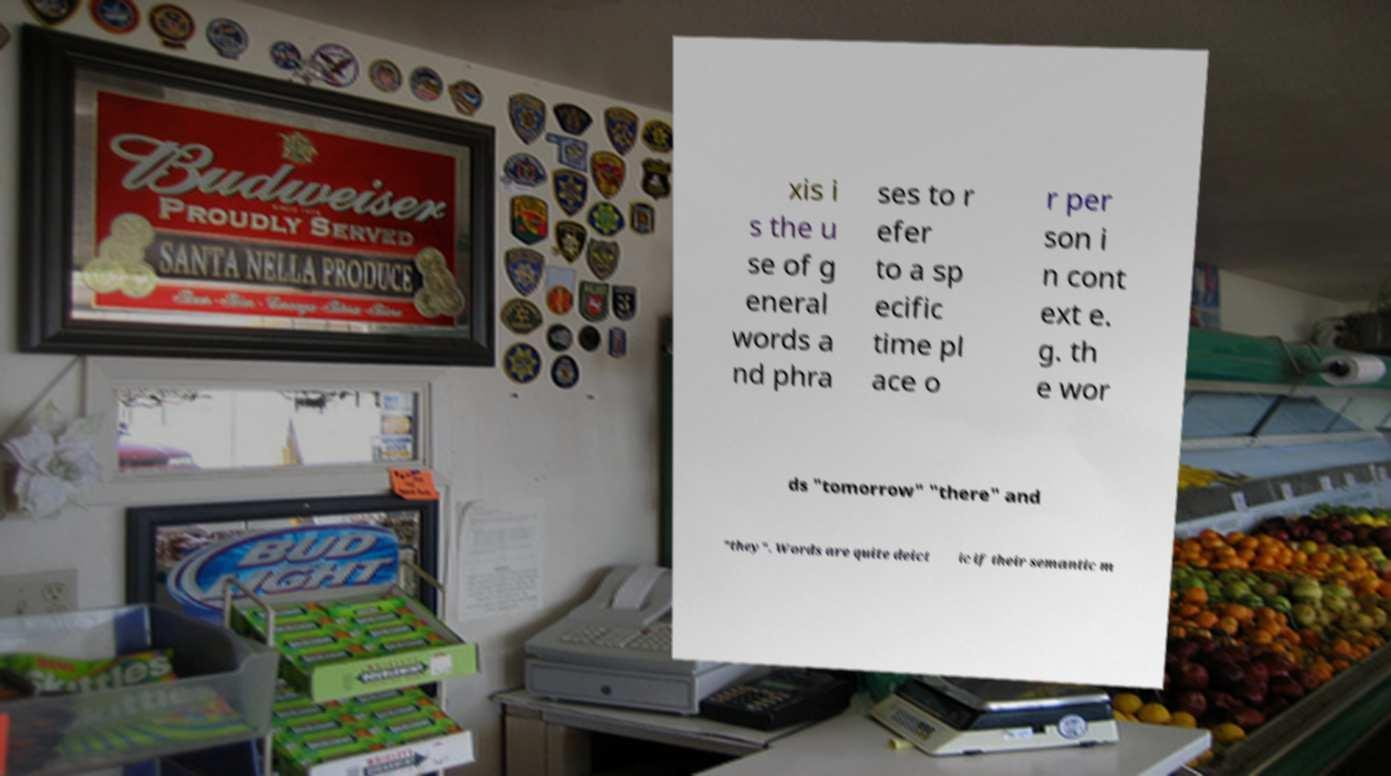Could you assist in decoding the text presented in this image and type it out clearly? xis i s the u se of g eneral words a nd phra ses to r efer to a sp ecific time pl ace o r per son i n cont ext e. g. th e wor ds "tomorrow" "there" and "they". Words are quite deict ic if their semantic m 